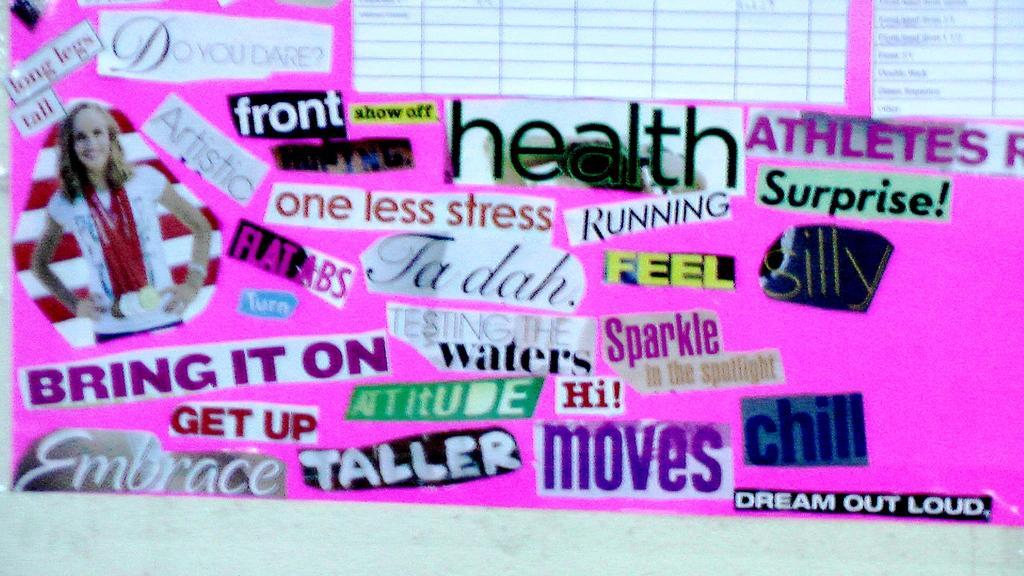How would you summarize this image in a sentence or two? This is a picture of a chart, on the chart there are various stickers. The chart is in pink color. 